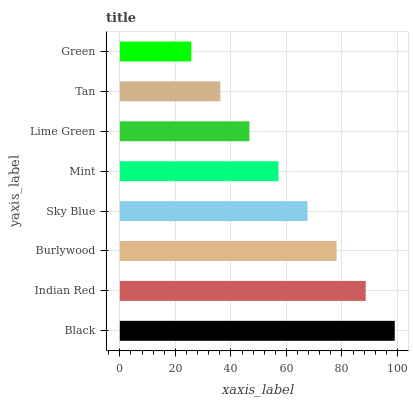Is Green the minimum?
Answer yes or no. Yes. Is Black the maximum?
Answer yes or no. Yes. Is Indian Red the minimum?
Answer yes or no. No. Is Indian Red the maximum?
Answer yes or no. No. Is Black greater than Indian Red?
Answer yes or no. Yes. Is Indian Red less than Black?
Answer yes or no. Yes. Is Indian Red greater than Black?
Answer yes or no. No. Is Black less than Indian Red?
Answer yes or no. No. Is Sky Blue the high median?
Answer yes or no. Yes. Is Mint the low median?
Answer yes or no. Yes. Is Lime Green the high median?
Answer yes or no. No. Is Sky Blue the low median?
Answer yes or no. No. 